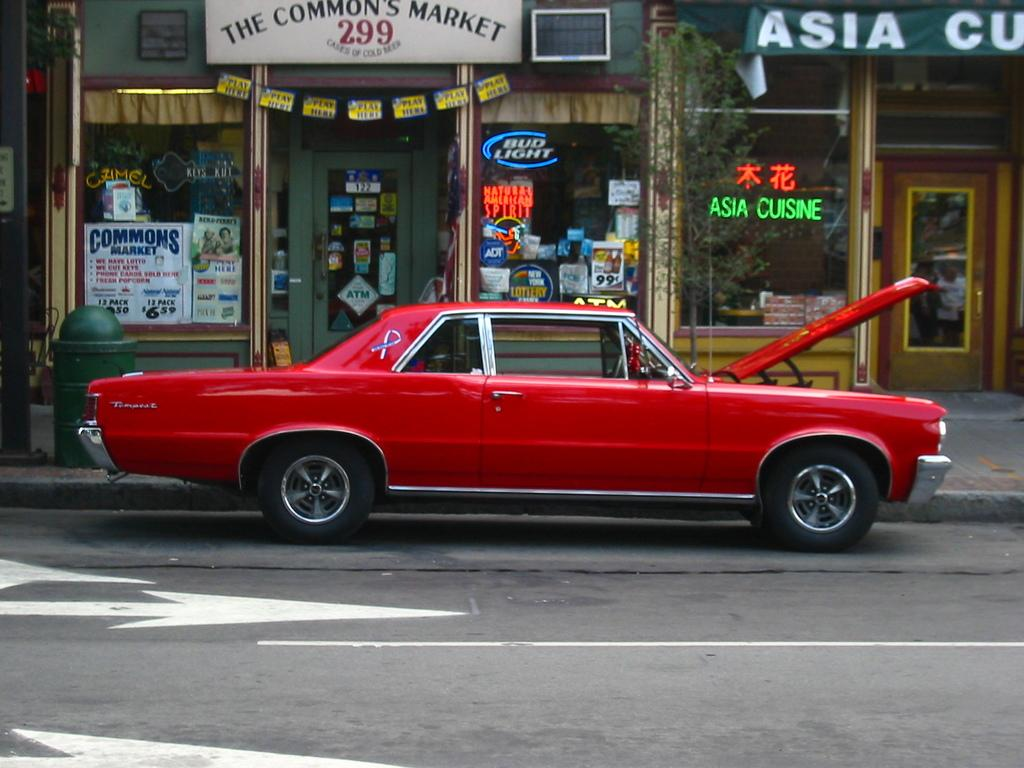<image>
Offer a succinct explanation of the picture presented. In front of the commons market is a old muscle car. 